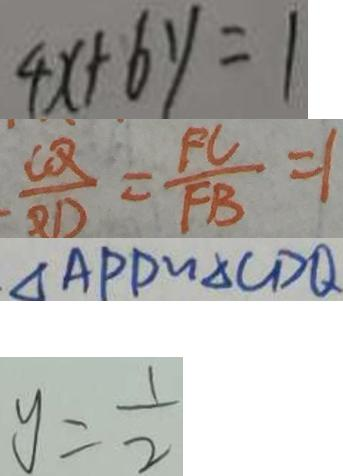<formula> <loc_0><loc_0><loc_500><loc_500>4 x + 6 y = 1 
 \frac { C Q } { B D } = \frac { F C } { F B } = 1 
 \Delta A P D \sim \Delta C D Q 
 y = \frac { 1 } { 2 }</formula> 